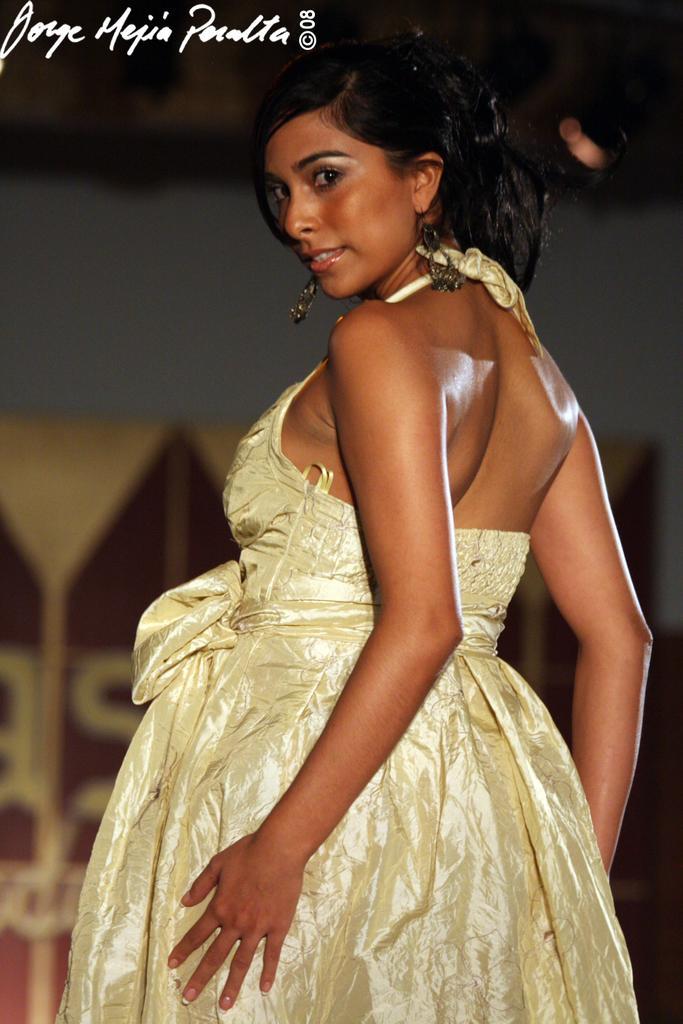Please provide a concise description of this image. In this picture there is a girl in the center of the image and there is a poster in the background area of the image. 